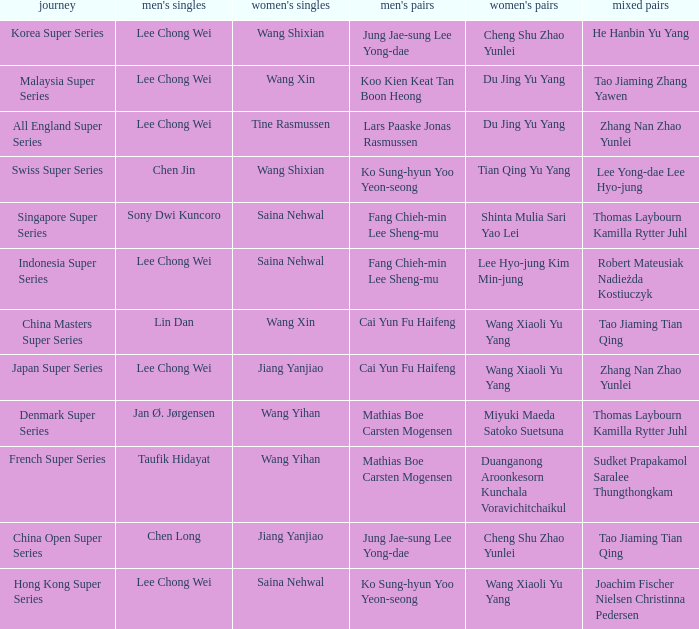Who were the womens doubles when the mixed doubles were zhang nan zhao yunlei on the tour all england super series? Du Jing Yu Yang. 